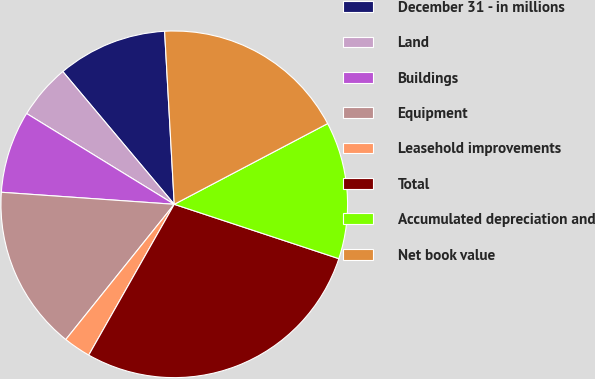<chart> <loc_0><loc_0><loc_500><loc_500><pie_chart><fcel>December 31 - in millions<fcel>Land<fcel>Buildings<fcel>Equipment<fcel>Leasehold improvements<fcel>Total<fcel>Accumulated depreciation and<fcel>Net book value<nl><fcel>10.23%<fcel>5.11%<fcel>7.67%<fcel>15.35%<fcel>2.55%<fcel>28.14%<fcel>12.79%<fcel>18.18%<nl></chart> 